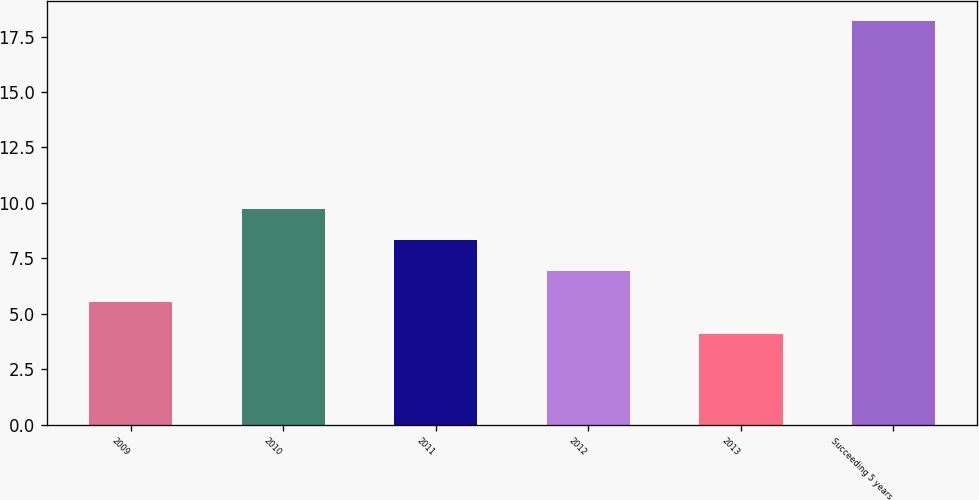Convert chart to OTSL. <chart><loc_0><loc_0><loc_500><loc_500><bar_chart><fcel>2009<fcel>2010<fcel>2011<fcel>2012<fcel>2013<fcel>Succeeding 5 years<nl><fcel>5.51<fcel>9.74<fcel>8.33<fcel>6.92<fcel>4.1<fcel>18.2<nl></chart> 